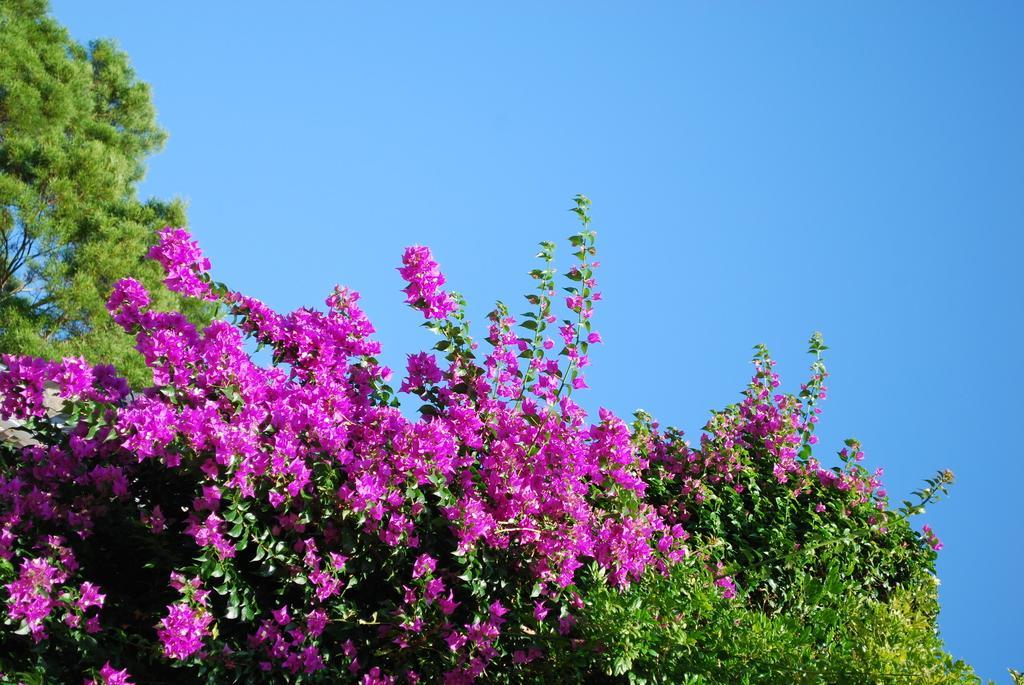Please provide a concise description of this image. In this picture we can see the trees and flowers. In the background of the image we can see the sky. 